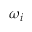Convert formula to latex. <formula><loc_0><loc_0><loc_500><loc_500>\omega _ { i }</formula> 